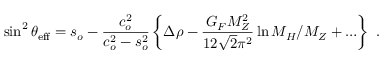Convert formula to latex. <formula><loc_0><loc_0><loc_500><loc_500>\sin ^ { 2 } \theta _ { e f f } = s _ { o } - \frac { c _ { o } ^ { 2 } } { c _ { o } ^ { 2 } - s _ { o } ^ { 2 } } \left \{ \Delta \rho - \frac { G _ { F } M _ { Z } ^ { 2 } } { 1 2 \sqrt { 2 } \pi ^ { 2 } } \ln M _ { H } / M _ { Z } + \dots \right \} .</formula> 